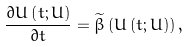Convert formula to latex. <formula><loc_0><loc_0><loc_500><loc_500>\frac { \partial U \left ( t ; U \right ) } { \partial t } = \widetilde { \beta } \left ( U \left ( t ; U \right ) \right ) ,</formula> 